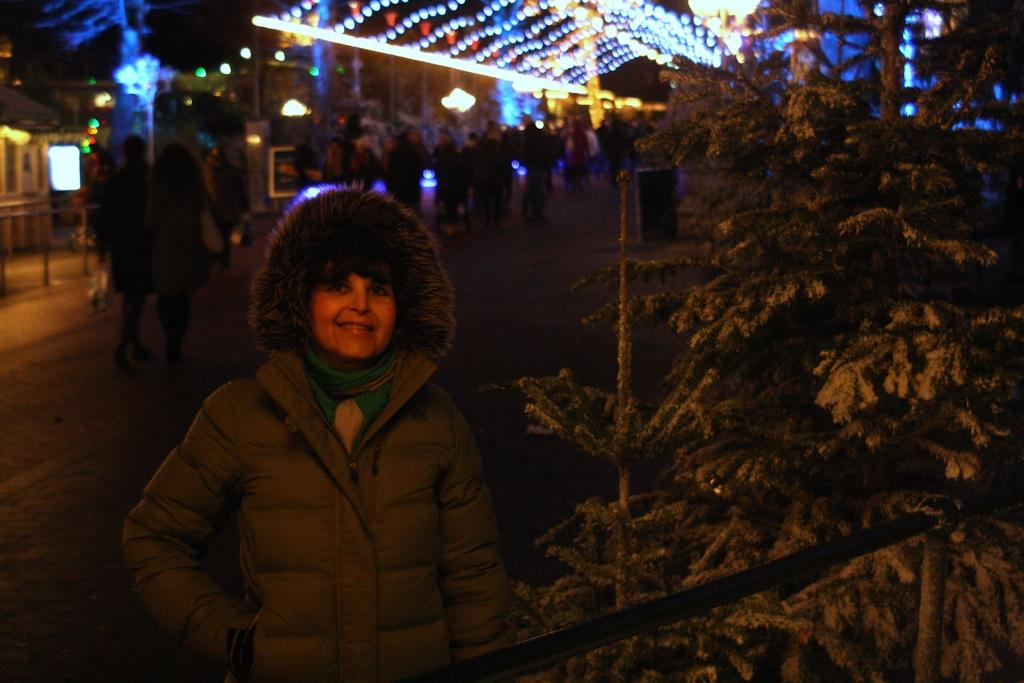What type of vegetation can be seen in the image? There are plants and trees in the image. What is happening on the road in the image? There is a crowd on the road in the image. What can be seen illuminating the scene in the image? Decoration lights are visible in the image. What type of structures are present in the image? There are buildings in the image. What type of barrier is present in the image? There is a fence in the image. Can you determine the time of day the image was taken? The image may have been taken during the night, as the decoration lights are visible. What type of writing can be seen on the fence in the image? There is no writing visible on the fence in the image. What type of wire is used to connect the appliances in the image? There are no appliances present in the image, so it is not possible to determine what type of wire might be used to connect them. 